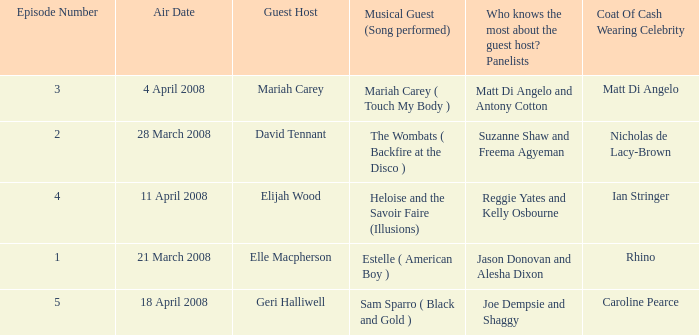Name the total number of coat of cash wearing celebrity where panelists are matt di angelo and antony cotton 1.0. 